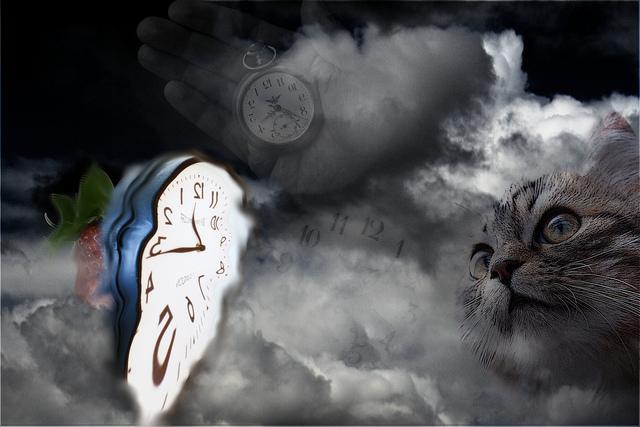What color is the clock?
Quick response, please. White. Can a cat read a clock?
Answer briefly. No. Who painted this?
Concise answer only. Artist. 